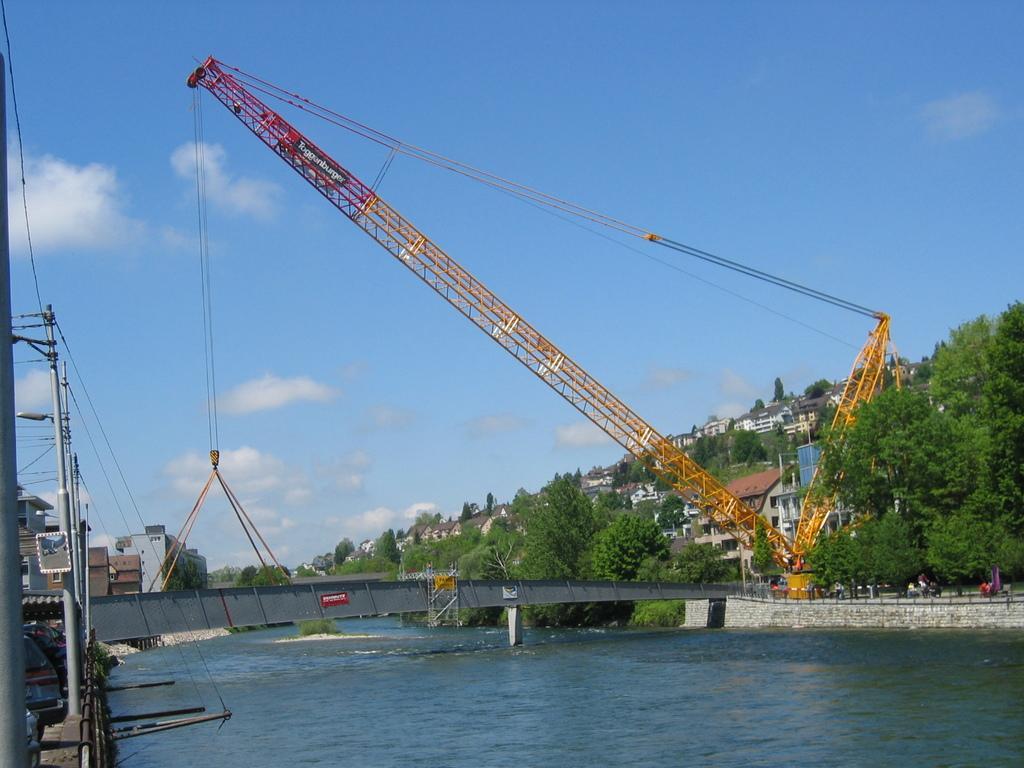In one or two sentences, can you explain what this image depicts? To the left side of the image there are electric wires and poles. In the background of the image there are houses, trees. There is a crane. At the bottom of the image there is water. In the center of the image there is a bridge. At the top of the image there is sky. 